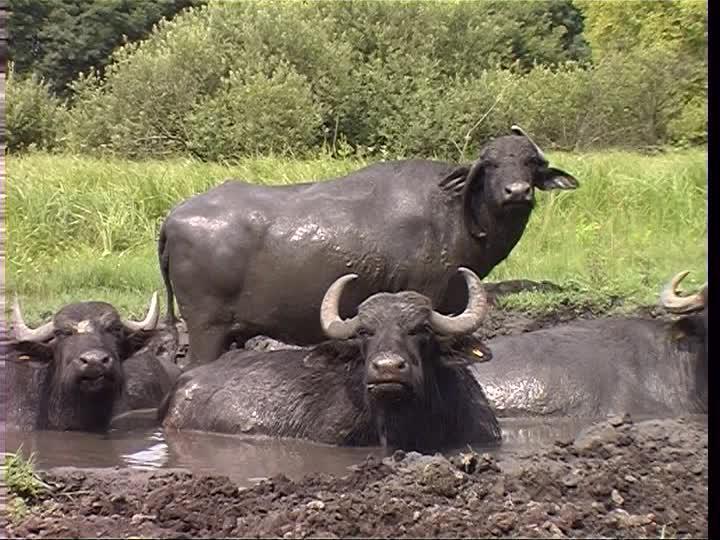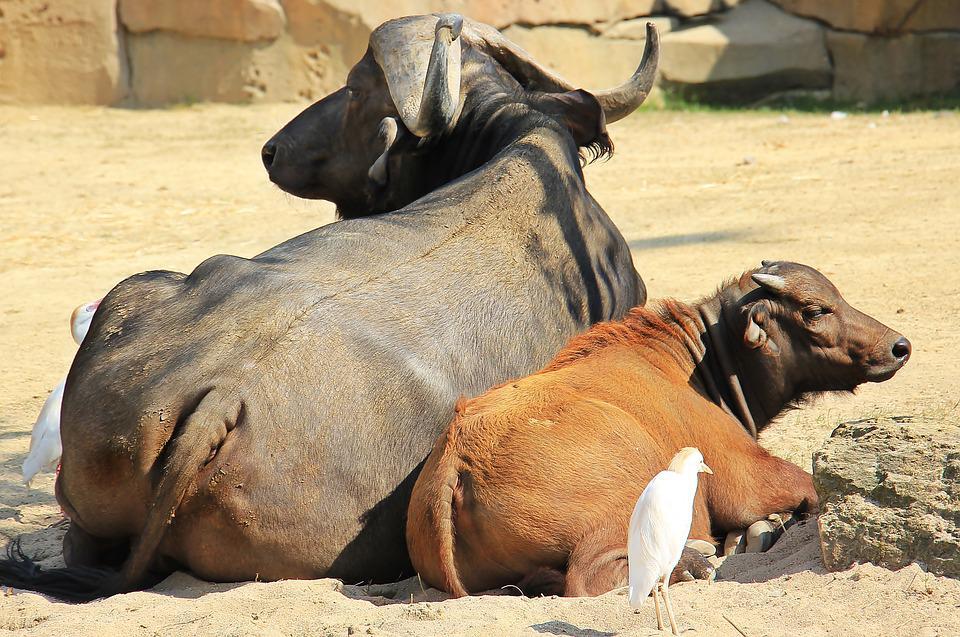The first image is the image on the left, the second image is the image on the right. Considering the images on both sides, is "All water buffalo are standing, and no water buffalo are in a scene with other types of mammals." valid? Answer yes or no. No. The first image is the image on the left, the second image is the image on the right. Analyze the images presented: Is the assertion "There is at least one white bird in the right image." valid? Answer yes or no. Yes. 